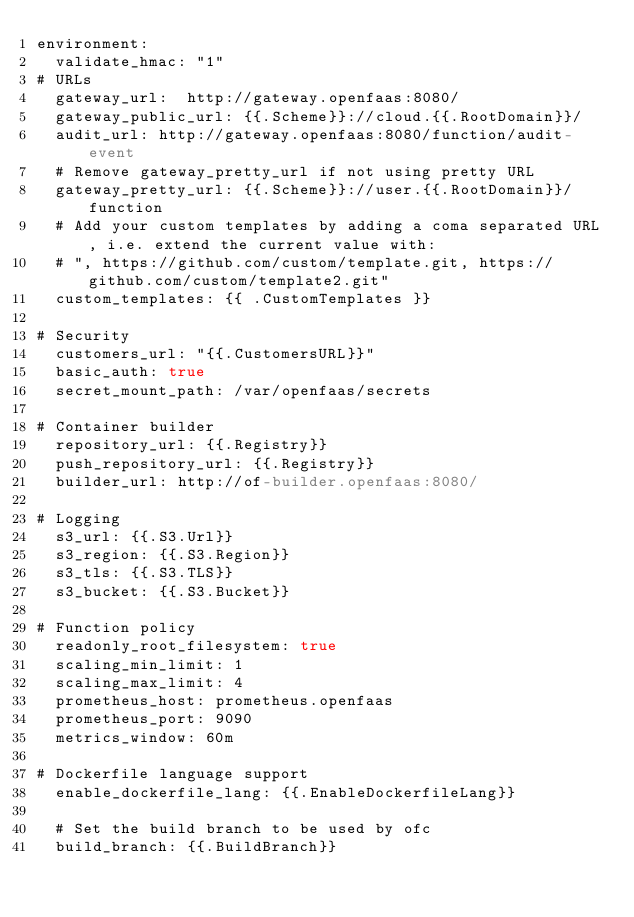Convert code to text. <code><loc_0><loc_0><loc_500><loc_500><_YAML_>environment:
  validate_hmac: "1"
# URLs
  gateway_url:  http://gateway.openfaas:8080/
  gateway_public_url: {{.Scheme}}://cloud.{{.RootDomain}}/
  audit_url: http://gateway.openfaas:8080/function/audit-event
  # Remove gateway_pretty_url if not using pretty URL
  gateway_pretty_url: {{.Scheme}}://user.{{.RootDomain}}/function
  # Add your custom templates by adding a coma separated URL, i.e. extend the current value with:
  # ", https://github.com/custom/template.git, https://github.com/custom/template2.git"
  custom_templates: {{ .CustomTemplates }}

# Security
  customers_url: "{{.CustomersURL}}"
  basic_auth: true
  secret_mount_path: /var/openfaas/secrets

# Container builder
  repository_url: {{.Registry}}
  push_repository_url: {{.Registry}}
  builder_url: http://of-builder.openfaas:8080/

# Logging
  s3_url: {{.S3.Url}}
  s3_region: {{.S3.Region}}
  s3_tls: {{.S3.TLS}}
  s3_bucket: {{.S3.Bucket}}

# Function policy
  readonly_root_filesystem: true
  scaling_min_limit: 1
  scaling_max_limit: 4
  prometheus_host: prometheus.openfaas
  prometheus_port: 9090
  metrics_window: 60m

# Dockerfile language support
  enable_dockerfile_lang: {{.EnableDockerfileLang}}

  # Set the build branch to be used by ofc
  build_branch: {{.BuildBranch}}

</code> 